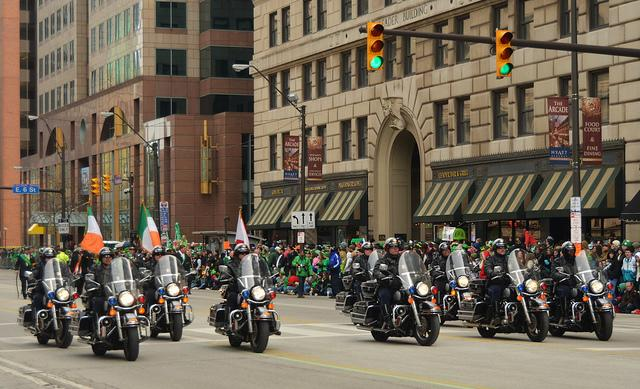Which nation is the motorcade of police motorcycles celebrating? Please explain your reasoning. ireland. A group of men in uniform on motorcycles have the irish flag with them. 